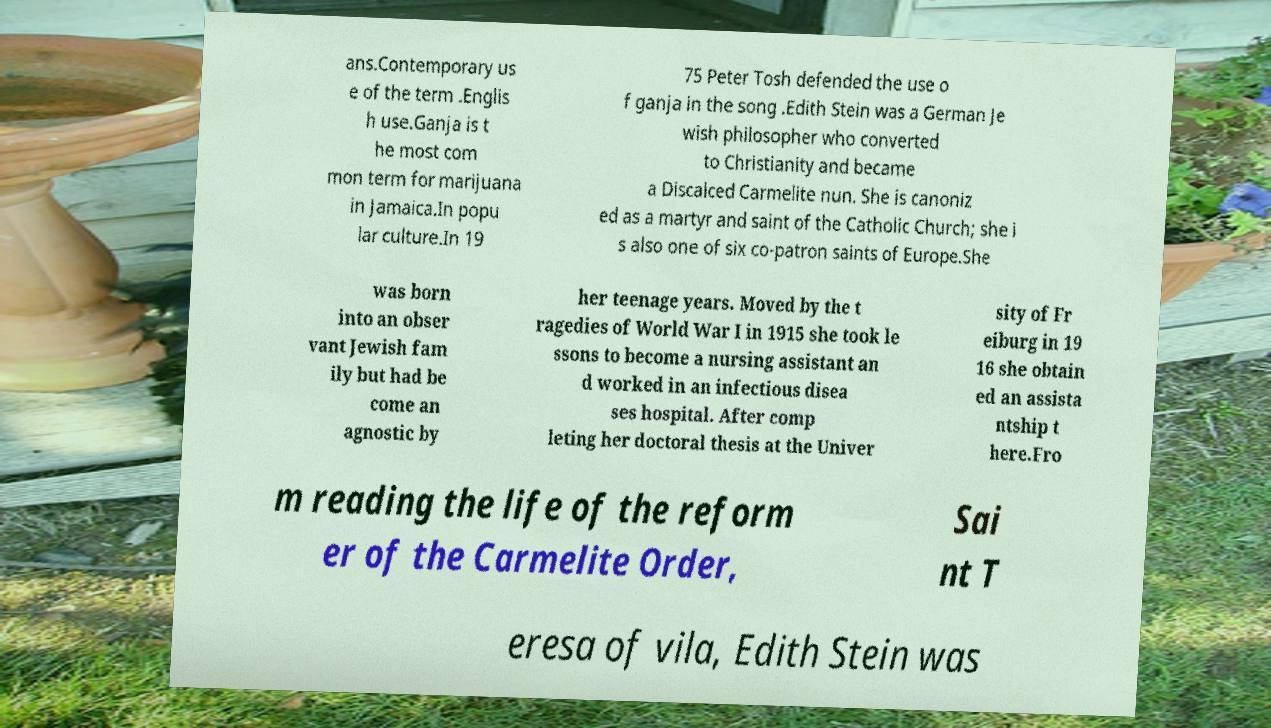Can you read and provide the text displayed in the image?This photo seems to have some interesting text. Can you extract and type it out for me? ans.Contemporary us e of the term .Englis h use.Ganja is t he most com mon term for marijuana in Jamaica.In popu lar culture.In 19 75 Peter Tosh defended the use o f ganja in the song .Edith Stein was a German Je wish philosopher who converted to Christianity and became a Discalced Carmelite nun. She is canoniz ed as a martyr and saint of the Catholic Church; she i s also one of six co-patron saints of Europe.She was born into an obser vant Jewish fam ily but had be come an agnostic by her teenage years. Moved by the t ragedies of World War I in 1915 she took le ssons to become a nursing assistant an d worked in an infectious disea ses hospital. After comp leting her doctoral thesis at the Univer sity of Fr eiburg in 19 16 she obtain ed an assista ntship t here.Fro m reading the life of the reform er of the Carmelite Order, Sai nt T eresa of vila, Edith Stein was 